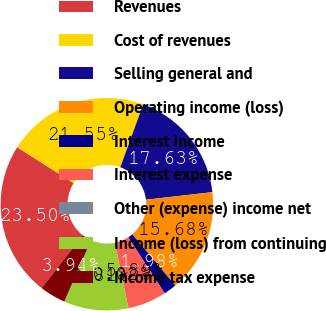Convert chart. <chart><loc_0><loc_0><loc_500><loc_500><pie_chart><fcel>Revenues<fcel>Cost of revenues<fcel>Selling general and<fcel>Operating income (loss)<fcel>Interest income<fcel>Interest expense<fcel>Other (expense) income net<fcel>Income (loss) from continuing<fcel>Income tax expense<nl><fcel>23.5%<fcel>21.55%<fcel>17.63%<fcel>15.68%<fcel>1.98%<fcel>5.89%<fcel>0.02%<fcel>9.81%<fcel>3.94%<nl></chart> 